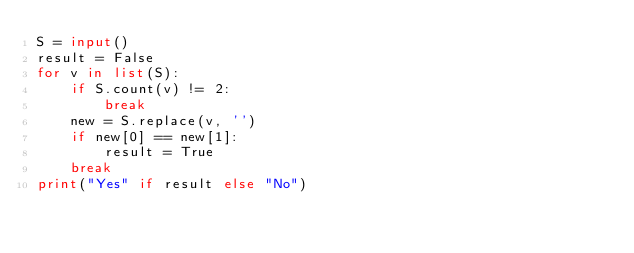<code> <loc_0><loc_0><loc_500><loc_500><_Python_>S = input()
result = False
for v in list(S):
    if S.count(v) != 2:
        break
    new = S.replace(v, '')
    if new[0] == new[1]:
        result = True
    break
print("Yes" if result else "No")</code> 